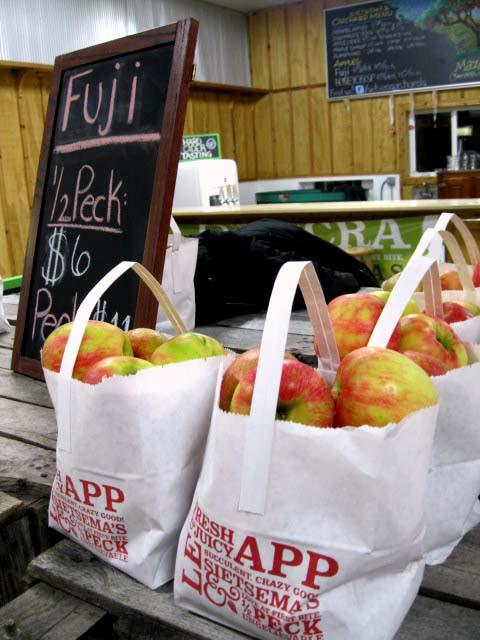What color is the text on the bags?
Write a very short answer. Red. Is this a pizza?
Answer briefly. No. What is written on the chalkboard?
Give a very brief answer. Fuji. 